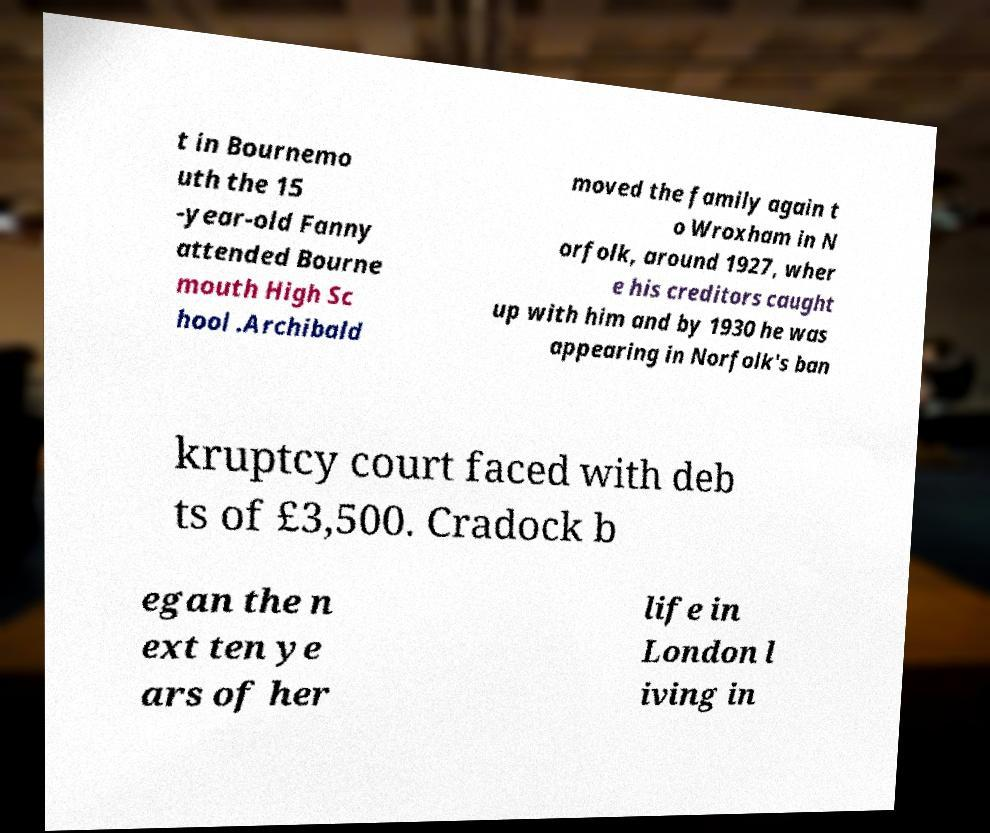What messages or text are displayed in this image? I need them in a readable, typed format. t in Bournemo uth the 15 -year-old Fanny attended Bourne mouth High Sc hool .Archibald moved the family again t o Wroxham in N orfolk, around 1927, wher e his creditors caught up with him and by 1930 he was appearing in Norfolk's ban kruptcy court faced with deb ts of £3,500. Cradock b egan the n ext ten ye ars of her life in London l iving in 